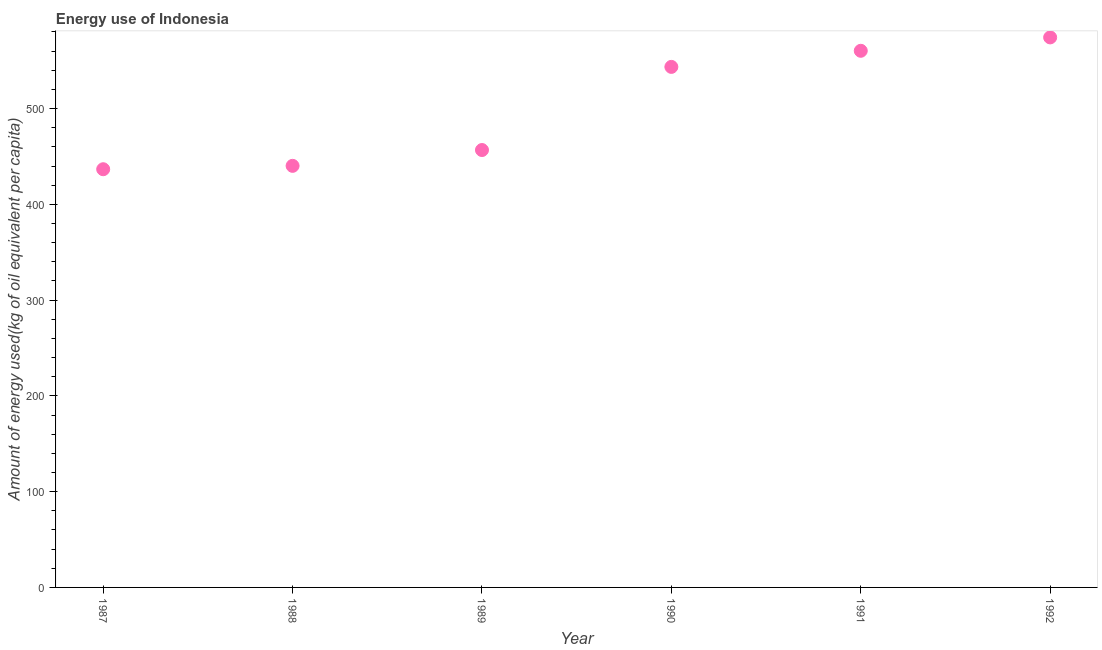What is the amount of energy used in 1987?
Provide a short and direct response. 436.66. Across all years, what is the maximum amount of energy used?
Offer a very short reply. 574.3. Across all years, what is the minimum amount of energy used?
Keep it short and to the point. 436.66. In which year was the amount of energy used maximum?
Provide a succinct answer. 1992. In which year was the amount of energy used minimum?
Your answer should be very brief. 1987. What is the sum of the amount of energy used?
Your answer should be compact. 3011.7. What is the difference between the amount of energy used in 1987 and 1992?
Offer a very short reply. -137.63. What is the average amount of energy used per year?
Provide a succinct answer. 501.95. What is the median amount of energy used?
Provide a short and direct response. 500.11. What is the ratio of the amount of energy used in 1991 to that in 1992?
Provide a short and direct response. 0.98. Is the amount of energy used in 1989 less than that in 1991?
Your answer should be very brief. Yes. Is the difference between the amount of energy used in 1988 and 1989 greater than the difference between any two years?
Provide a short and direct response. No. What is the difference between the highest and the second highest amount of energy used?
Give a very brief answer. 13.97. Is the sum of the amount of energy used in 1990 and 1992 greater than the maximum amount of energy used across all years?
Ensure brevity in your answer.  Yes. What is the difference between the highest and the lowest amount of energy used?
Make the answer very short. 137.63. Does the amount of energy used monotonically increase over the years?
Provide a short and direct response. Yes. How many years are there in the graph?
Give a very brief answer. 6. What is the difference between two consecutive major ticks on the Y-axis?
Offer a very short reply. 100. Does the graph contain any zero values?
Your response must be concise. No. Does the graph contain grids?
Keep it short and to the point. No. What is the title of the graph?
Your response must be concise. Energy use of Indonesia. What is the label or title of the Y-axis?
Offer a very short reply. Amount of energy used(kg of oil equivalent per capita). What is the Amount of energy used(kg of oil equivalent per capita) in 1987?
Offer a very short reply. 436.66. What is the Amount of energy used(kg of oil equivalent per capita) in 1988?
Provide a succinct answer. 440.18. What is the Amount of energy used(kg of oil equivalent per capita) in 1989?
Your answer should be very brief. 456.71. What is the Amount of energy used(kg of oil equivalent per capita) in 1990?
Offer a terse response. 543.52. What is the Amount of energy used(kg of oil equivalent per capita) in 1991?
Ensure brevity in your answer.  560.33. What is the Amount of energy used(kg of oil equivalent per capita) in 1992?
Your response must be concise. 574.3. What is the difference between the Amount of energy used(kg of oil equivalent per capita) in 1987 and 1988?
Make the answer very short. -3.52. What is the difference between the Amount of energy used(kg of oil equivalent per capita) in 1987 and 1989?
Your answer should be compact. -20.05. What is the difference between the Amount of energy used(kg of oil equivalent per capita) in 1987 and 1990?
Provide a succinct answer. -106.85. What is the difference between the Amount of energy used(kg of oil equivalent per capita) in 1987 and 1991?
Provide a succinct answer. -123.67. What is the difference between the Amount of energy used(kg of oil equivalent per capita) in 1987 and 1992?
Your response must be concise. -137.63. What is the difference between the Amount of energy used(kg of oil equivalent per capita) in 1988 and 1989?
Keep it short and to the point. -16.53. What is the difference between the Amount of energy used(kg of oil equivalent per capita) in 1988 and 1990?
Your answer should be very brief. -103.33. What is the difference between the Amount of energy used(kg of oil equivalent per capita) in 1988 and 1991?
Your answer should be compact. -120.14. What is the difference between the Amount of energy used(kg of oil equivalent per capita) in 1988 and 1992?
Your answer should be compact. -134.11. What is the difference between the Amount of energy used(kg of oil equivalent per capita) in 1989 and 1990?
Offer a very short reply. -86.81. What is the difference between the Amount of energy used(kg of oil equivalent per capita) in 1989 and 1991?
Ensure brevity in your answer.  -103.62. What is the difference between the Amount of energy used(kg of oil equivalent per capita) in 1989 and 1992?
Offer a terse response. -117.59. What is the difference between the Amount of energy used(kg of oil equivalent per capita) in 1990 and 1991?
Your answer should be compact. -16.81. What is the difference between the Amount of energy used(kg of oil equivalent per capita) in 1990 and 1992?
Offer a terse response. -30.78. What is the difference between the Amount of energy used(kg of oil equivalent per capita) in 1991 and 1992?
Offer a very short reply. -13.97. What is the ratio of the Amount of energy used(kg of oil equivalent per capita) in 1987 to that in 1989?
Your answer should be very brief. 0.96. What is the ratio of the Amount of energy used(kg of oil equivalent per capita) in 1987 to that in 1990?
Your response must be concise. 0.8. What is the ratio of the Amount of energy used(kg of oil equivalent per capita) in 1987 to that in 1991?
Provide a short and direct response. 0.78. What is the ratio of the Amount of energy used(kg of oil equivalent per capita) in 1987 to that in 1992?
Provide a short and direct response. 0.76. What is the ratio of the Amount of energy used(kg of oil equivalent per capita) in 1988 to that in 1990?
Your response must be concise. 0.81. What is the ratio of the Amount of energy used(kg of oil equivalent per capita) in 1988 to that in 1991?
Provide a succinct answer. 0.79. What is the ratio of the Amount of energy used(kg of oil equivalent per capita) in 1988 to that in 1992?
Offer a terse response. 0.77. What is the ratio of the Amount of energy used(kg of oil equivalent per capita) in 1989 to that in 1990?
Offer a very short reply. 0.84. What is the ratio of the Amount of energy used(kg of oil equivalent per capita) in 1989 to that in 1991?
Ensure brevity in your answer.  0.81. What is the ratio of the Amount of energy used(kg of oil equivalent per capita) in 1989 to that in 1992?
Give a very brief answer. 0.8. What is the ratio of the Amount of energy used(kg of oil equivalent per capita) in 1990 to that in 1992?
Your response must be concise. 0.95. What is the ratio of the Amount of energy used(kg of oil equivalent per capita) in 1991 to that in 1992?
Ensure brevity in your answer.  0.98. 